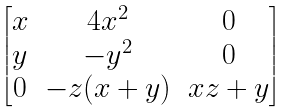Convert formula to latex. <formula><loc_0><loc_0><loc_500><loc_500>\begin{bmatrix} x & 4 x ^ { 2 } & 0 \\ y & - y ^ { 2 } & 0 \\ 0 & - z ( x + y ) & x z + y \\ \end{bmatrix}</formula> 